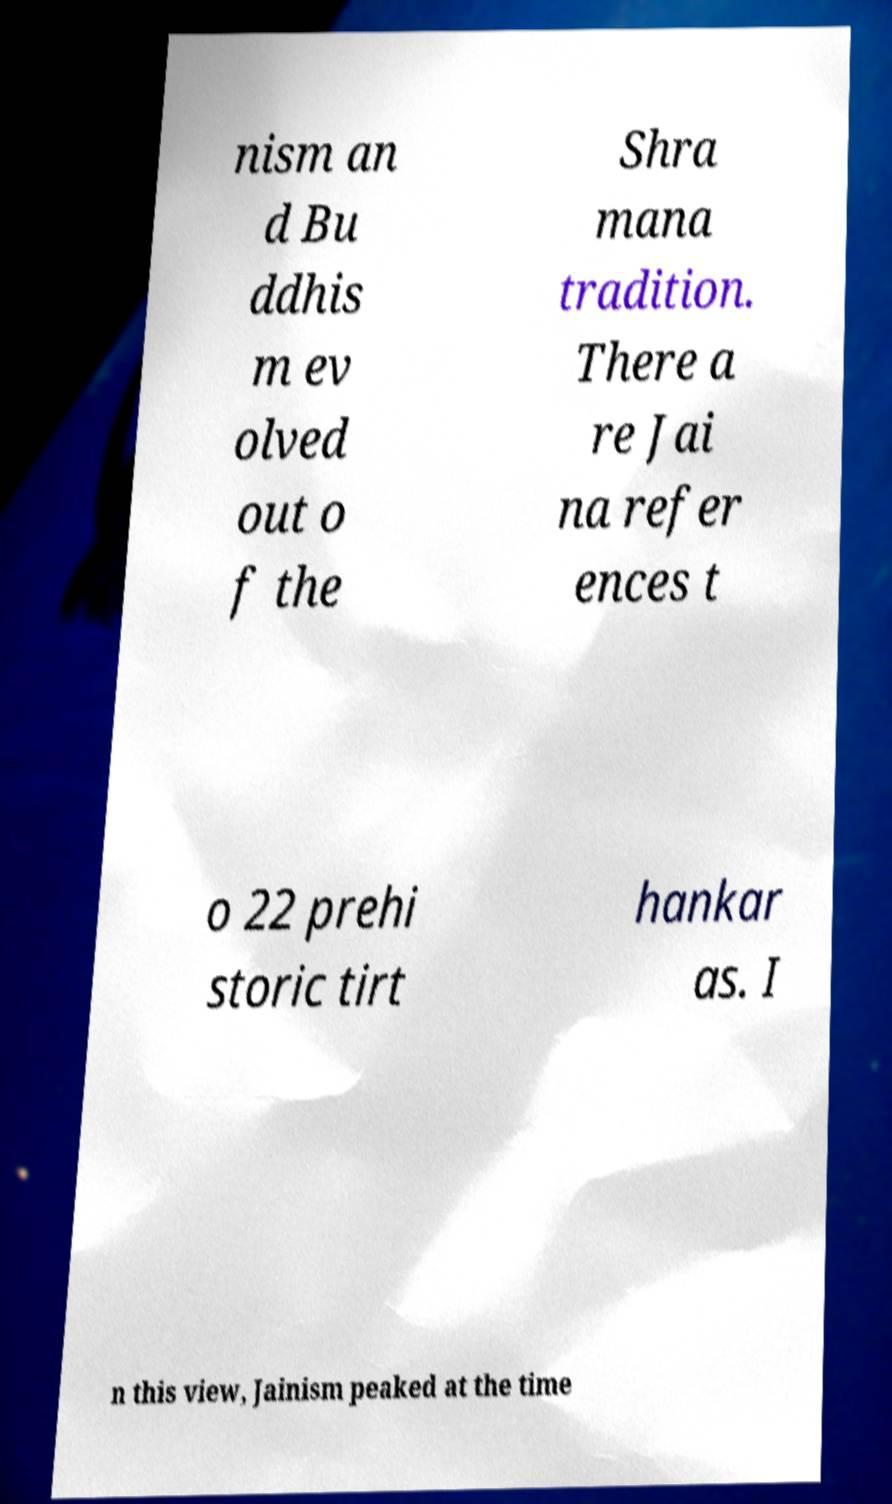For documentation purposes, I need the text within this image transcribed. Could you provide that? nism an d Bu ddhis m ev olved out o f the Shra mana tradition. There a re Jai na refer ences t o 22 prehi storic tirt hankar as. I n this view, Jainism peaked at the time 